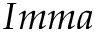<formula> <loc_0><loc_0><loc_500><loc_500>I m m a</formula> 